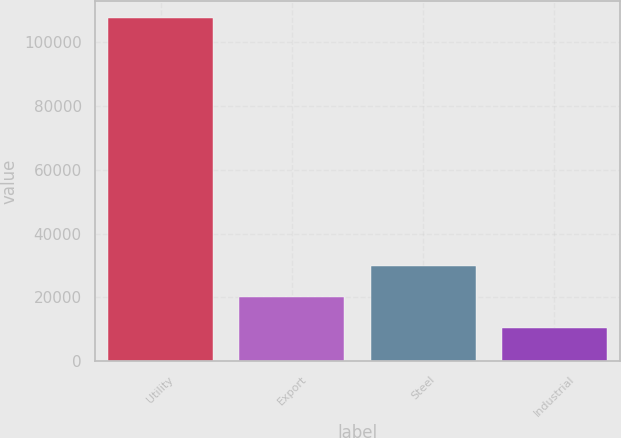Convert chart. <chart><loc_0><loc_0><loc_500><loc_500><bar_chart><fcel>Utility<fcel>Export<fcel>Steel<fcel>Industrial<nl><fcel>107381<fcel>20051.3<fcel>29754.6<fcel>10348<nl></chart> 